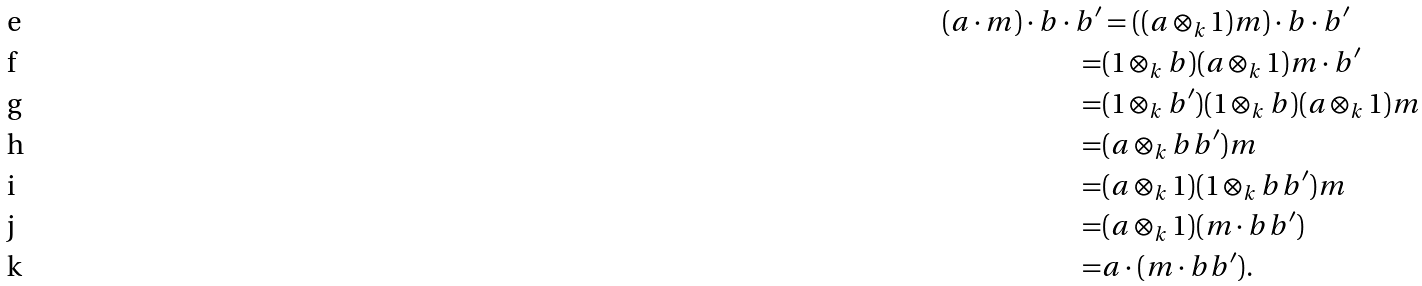Convert formula to latex. <formula><loc_0><loc_0><loc_500><loc_500>( a \cdot m ) \cdot b \cdot b ^ { \prime } & = ( ( a \otimes _ { k } 1 ) m ) \cdot b \cdot b ^ { \prime } \\ = & ( 1 \otimes _ { k } b ) ( a \otimes _ { k } 1 ) m \cdot b ^ { \prime } \\ = & ( 1 \otimes _ { k } b ^ { \prime } ) ( 1 \otimes _ { k } b ) ( a \otimes _ { k } 1 ) m \\ = & ( a \otimes _ { k } b b ^ { \prime } ) m \\ = & ( a \otimes _ { k } 1 ) ( 1 \otimes _ { k } b b ^ { \prime } ) m \\ = & ( a \otimes _ { k } 1 ) ( m \cdot b b ^ { \prime } ) \\ = & a \cdot ( m \cdot b b ^ { \prime } ) .</formula> 